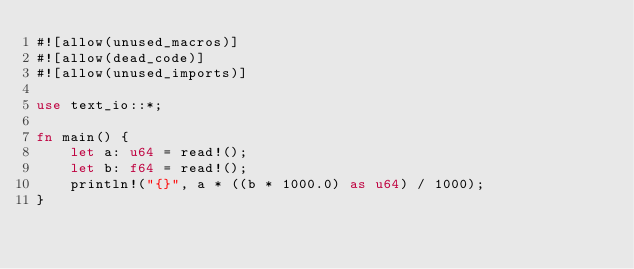Convert code to text. <code><loc_0><loc_0><loc_500><loc_500><_Rust_>#![allow(unused_macros)]
#![allow(dead_code)]
#![allow(unused_imports)]

use text_io::*;

fn main() {
    let a: u64 = read!();
    let b: f64 = read!();
    println!("{}", a * ((b * 1000.0) as u64) / 1000);
}
</code> 